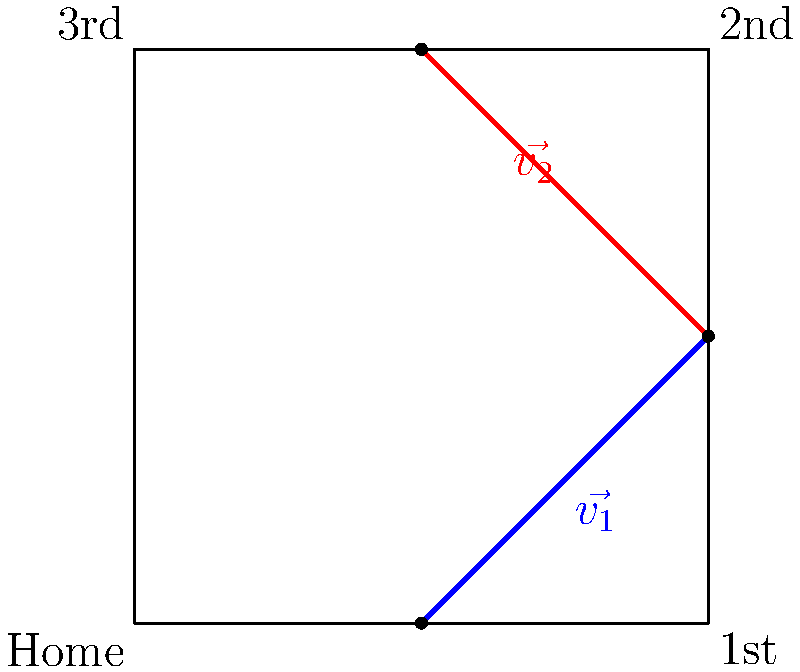In a crucial baseball game at PNC Park, a Pirates runner is attempting to score from first base on a double hit to right field. The runner's path can be broken down into two vectors: $\vec{v_1}$ from first base to second base, and $\vec{v_2}$ from second base towards home plate. If $\vec{v_1} = \langle 45, 45 \rangle$ feet and $\vec{v_2} = \langle -45, 45 \rangle$ feet, what is the magnitude of the resultant vector $\vec{R}$ representing the runner's total displacement? To solve this problem, we'll use vector addition and the Pythagorean theorem. Let's break it down step-by-step:

1) First, we need to add the two vectors $\vec{v_1}$ and $\vec{v_2}$:

   $\vec{R} = \vec{v_1} + \vec{v_2}$

2) $\vec{v_1} = \langle 45, 45 \rangle$ and $\vec{v_2} = \langle -45, 45 \rangle$

3) Adding these vectors:

   $\vec{R} = \langle 45, 45 \rangle + \langle -45, 45 \rangle = \langle 0, 90 \rangle$

4) The resultant vector $\vec{R}$ is $\langle 0, 90 \rangle$, which means the runner has moved 0 feet in the x-direction and 90 feet in the y-direction.

5) To find the magnitude of $\vec{R}$, we use the Pythagorean theorem:

   $|\vec{R}| = \sqrt{x^2 + y^2} = \sqrt{0^2 + 90^2} = \sqrt{8100} = 90$

6) Therefore, the magnitude of the resultant vector $\vec{R}$ is 90 feet.

This result makes sense in the context of a baseball diamond, as the distance from first base to third base (which is the runner's total displacement) is indeed 90 feet.
Answer: 90 feet 